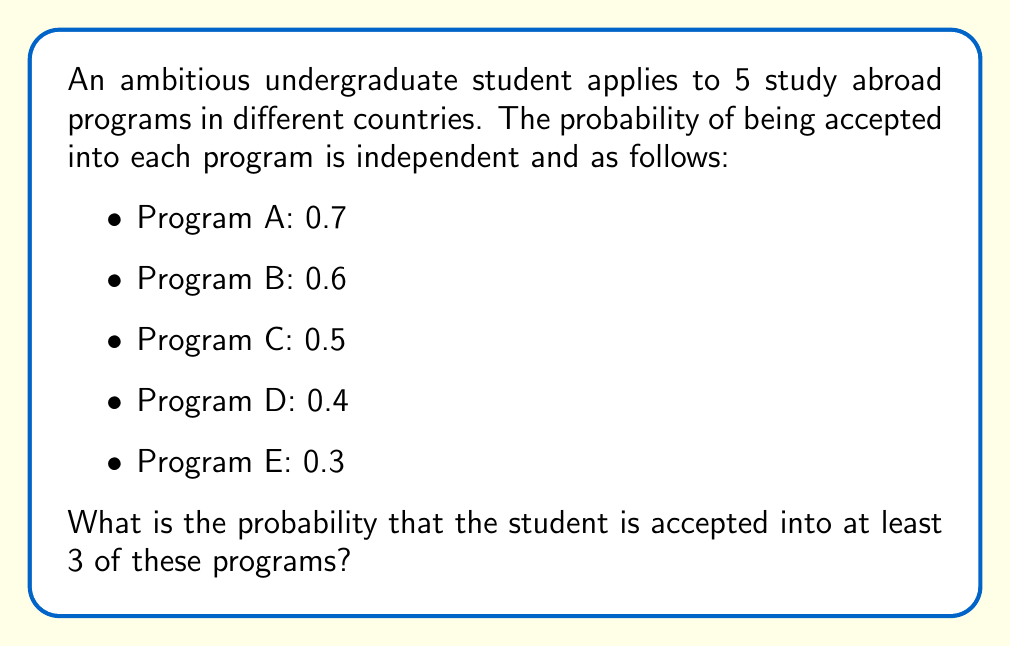Help me with this question. To solve this problem, we can use the complement of the probability of being accepted into 0, 1, or 2 programs.

Let's define success as being accepted and failure as being rejected.

Step 1: Calculate the probability of being rejected from each program:
- Program A: $1 - 0.7 = 0.3$
- Program B: $1 - 0.6 = 0.4$
- Program C: $1 - 0.5 = 0.5$
- Program D: $1 - 0.4 = 0.6$
- Program E: $1 - 0.3 = 0.7$

Step 2: Use the binomial probability formula to calculate the probability of being accepted into exactly 0, 1, and 2 programs:

$P(X = k) = \binom{n}{k} p^k (1-p)^{n-k}$

Where $n = 5$ (total number of programs), $k$ is the number of successes, and $p$ is the probability of success for each program.

For 0 acceptances:
$$P(X = 0) = (0.3 \times 0.4 \times 0.5 \times 0.6 \times 0.7) = 0.0252$$

For 1 acceptance:
$$P(X = 1) = (0.7 \times 0.4 \times 0.5 \times 0.6 \times 0.7) + (0.3 \times 0.6 \times 0.5 \times 0.6 \times 0.7) + (0.3 \times 0.4 \times 0.5 \times 0.6 \times 0.3) + (0.3 \times 0.4 \times 0.5 \times 0.4 \times 0.7) + (0.3 \times 0.4 \times 0.5 \times 0.6 \times 0.3) = 0.1176$$

For 2 acceptances:
$$P(X = 2) = \binom{5}{2}(0.7 \times 0.6 \times 0.5 \times 0.6 \times 0.7) + \binom{5}{2}(0.7 \times 0.6 \times 0.5 \times 0.4 \times 0.7) + \binom{5}{2}(0.7 \times 0.6 \times 0.5 \times 0.6 \times 0.3) + \binom{5}{2}(0.7 \times 0.4 \times 0.5 \times 0.6 \times 0.7) + \binom{5}{2}(0.3 \times 0.6 \times 0.5 \times 0.6 \times 0.7) = 0.2240$$

Step 3: Sum the probabilities of 0, 1, and 2 acceptances:
$$P(X \leq 2) = 0.0252 + 0.1176 + 0.2240 = 0.3668$$

Step 4: Calculate the complement to find the probability of at least 3 acceptances:
$$P(X \geq 3) = 1 - P(X \leq 2) = 1 - 0.3668 = 0.6332$$
Answer: The probability that the student is accepted into at least 3 of these programs is approximately 0.6332 or 63.32%. 